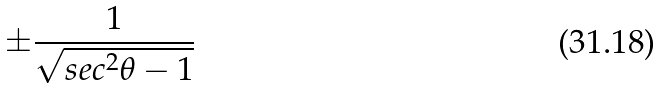Convert formula to latex. <formula><loc_0><loc_0><loc_500><loc_500>\pm \frac { 1 } { \sqrt { s e c ^ { 2 } \theta - 1 } }</formula> 